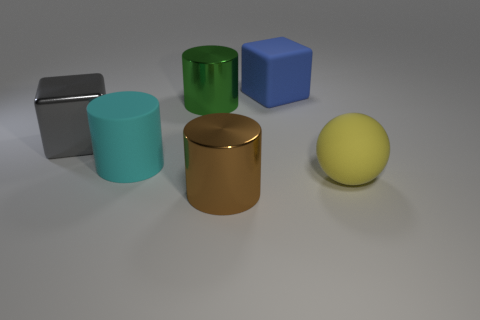Subtract all large rubber cylinders. How many cylinders are left? 2 Add 4 large blue blocks. How many objects exist? 10 Subtract all green cylinders. How many cylinders are left? 2 Subtract all spheres. How many objects are left? 5 Subtract all green blocks. How many brown cylinders are left? 1 Add 4 purple shiny cubes. How many purple shiny cubes exist? 4 Subtract 0 green cubes. How many objects are left? 6 Subtract 2 cylinders. How many cylinders are left? 1 Subtract all gray cylinders. Subtract all purple cubes. How many cylinders are left? 3 Subtract all big gray cubes. Subtract all rubber cubes. How many objects are left? 4 